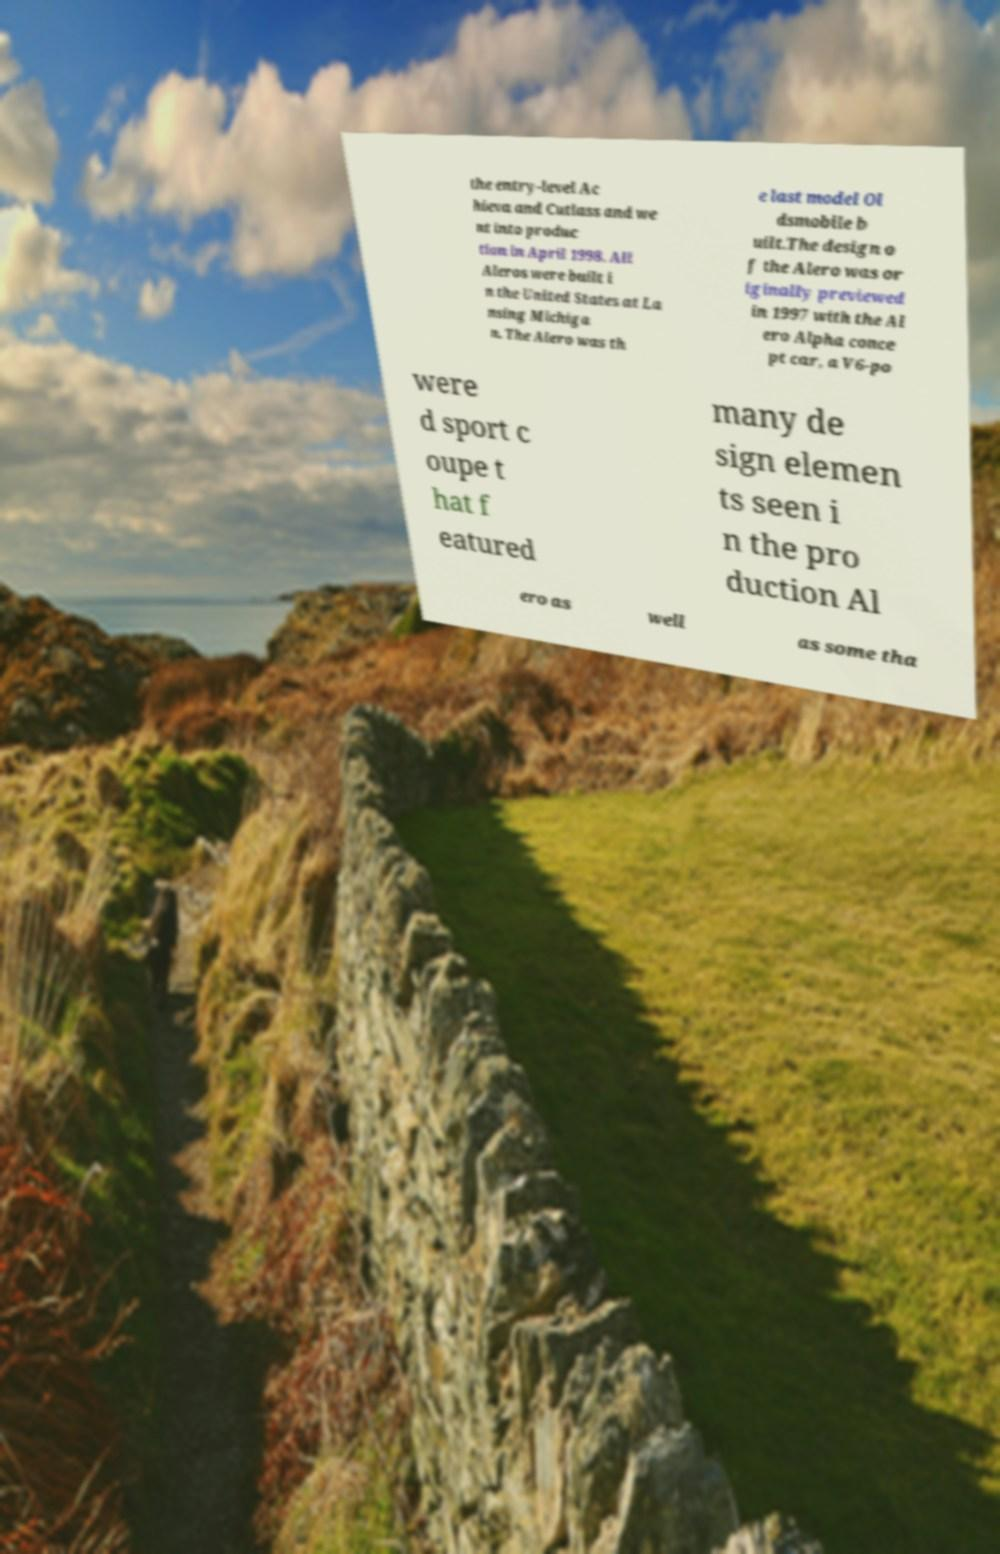Please identify and transcribe the text found in this image. the entry-level Ac hieva and Cutlass and we nt into produc tion in April 1998. All Aleros were built i n the United States at La nsing Michiga n. The Alero was th e last model Ol dsmobile b uilt.The design o f the Alero was or iginally previewed in 1997 with the Al ero Alpha conce pt car, a V6-po were d sport c oupe t hat f eatured many de sign elemen ts seen i n the pro duction Al ero as well as some tha 